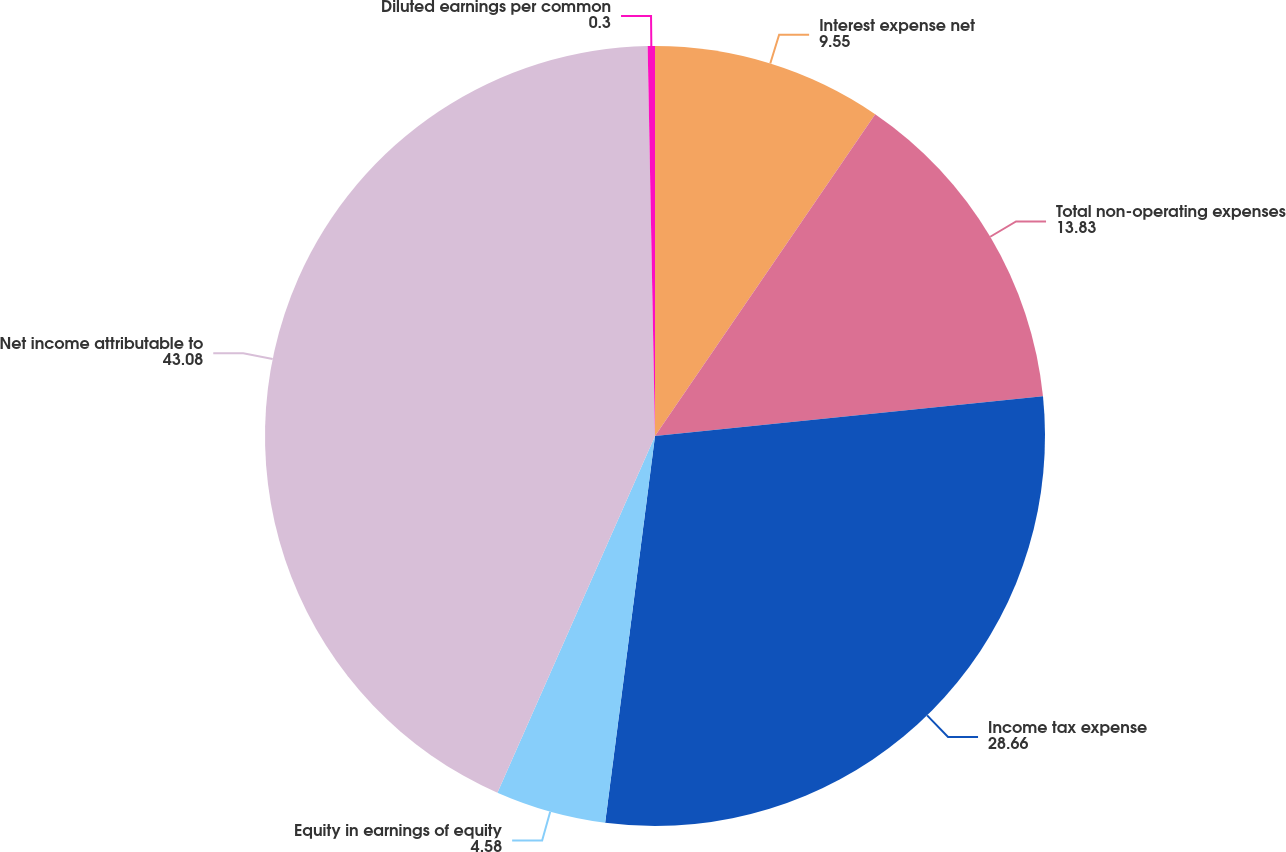Convert chart. <chart><loc_0><loc_0><loc_500><loc_500><pie_chart><fcel>Interest expense net<fcel>Total non-operating expenses<fcel>Income tax expense<fcel>Equity in earnings of equity<fcel>Net income attributable to<fcel>Diluted earnings per common<nl><fcel>9.55%<fcel>13.83%<fcel>28.66%<fcel>4.58%<fcel>43.08%<fcel>0.3%<nl></chart> 